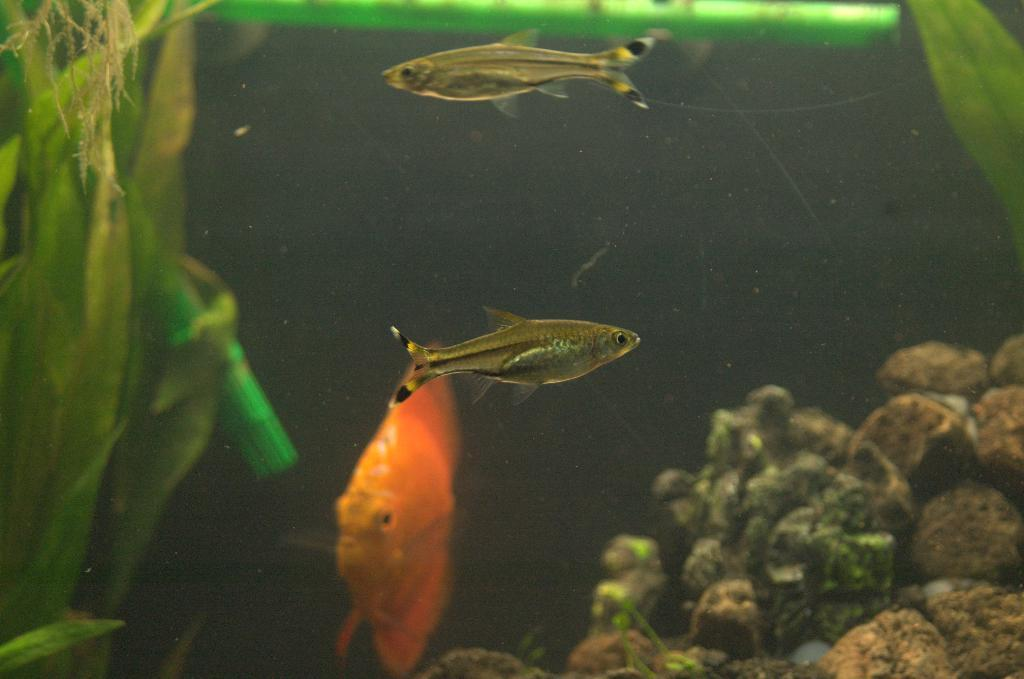What is happening in the water in the image? There are fishes swimming in the water. What can be seen on the left side of the image? There are plants on the left side of the image. What is present on the right side of the image? There are stones on the right side of the image. What type of flesh can be seen hanging from the plants in the image? There is no flesh present in the image; it features fishes swimming in the water and plants on the left side. Can you see someone's arm reaching for the stones in the image? There is no arm or person visible in the image; it only shows fishes, plants, and stones. 